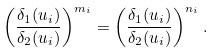<formula> <loc_0><loc_0><loc_500><loc_500>\left ( \frac { \delta _ { 1 } ( u _ { i } ) } { \delta _ { 2 } ( u _ { i } ) } \right ) ^ { m _ { i } } = \left ( \frac { \delta _ { 1 } ( u _ { i } ) } { \delta _ { 2 } ( u _ { i } ) } \right ) ^ { n _ { i } } .</formula> 